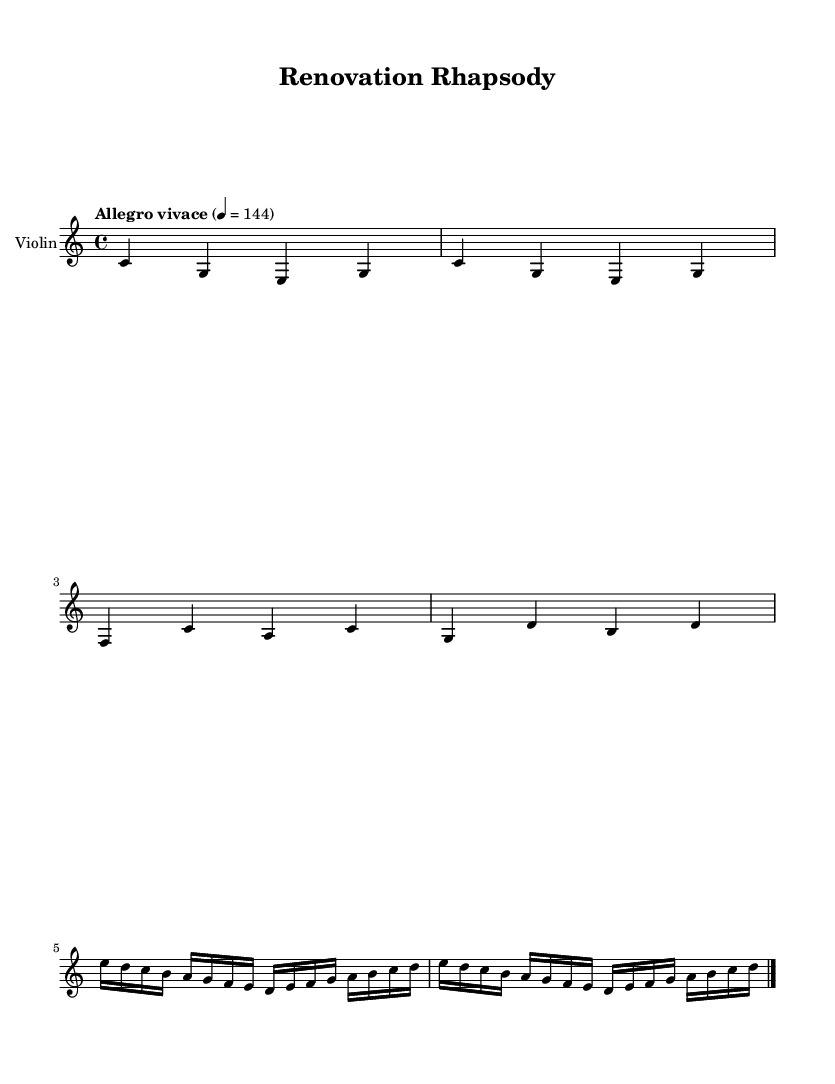What is the key signature of this music? The key signature is determined by the key indicated at the beginning of the score. In this case, it is C major, which has no sharps or flats.
Answer: C major What is the time signature of this music? The time signature is found near the start of the score and indicates how many beats are in each measure. Here, it is 4/4, meaning there are four beats per measure.
Answer: 4/4 What is the tempo marking of this music? The tempo marking is indicated at the beginning of the piece and describes how fast the music should be played. The marking here is "Allegro vivace," indicating a lively and fast tempo.
Answer: Allegro vivace How many measures are in the piece? To find the number of measures, count the measures in the score from beginning to end. There are four measures total in this excerpt.
Answer: 4 Which instrument is specified in the score? The instrument is listed at the start of the score, specifying which instrument the music is written for. Here, it is indicated as "Violin."
Answer: Violin What is the rhythmic value of the first note in the theme? The rhythmic value is determined by the note's shape and placement relative to the other symbols. The first note in the theme is a quarter note, indicated by its solid note head and stem.
Answer: Quarter note Which theme appears first in this piece? The themes in the piece are labeled as "themeA" and "themeB." The theme that appears first is "themeA," as it is listed first in the score.
Answer: themeA 